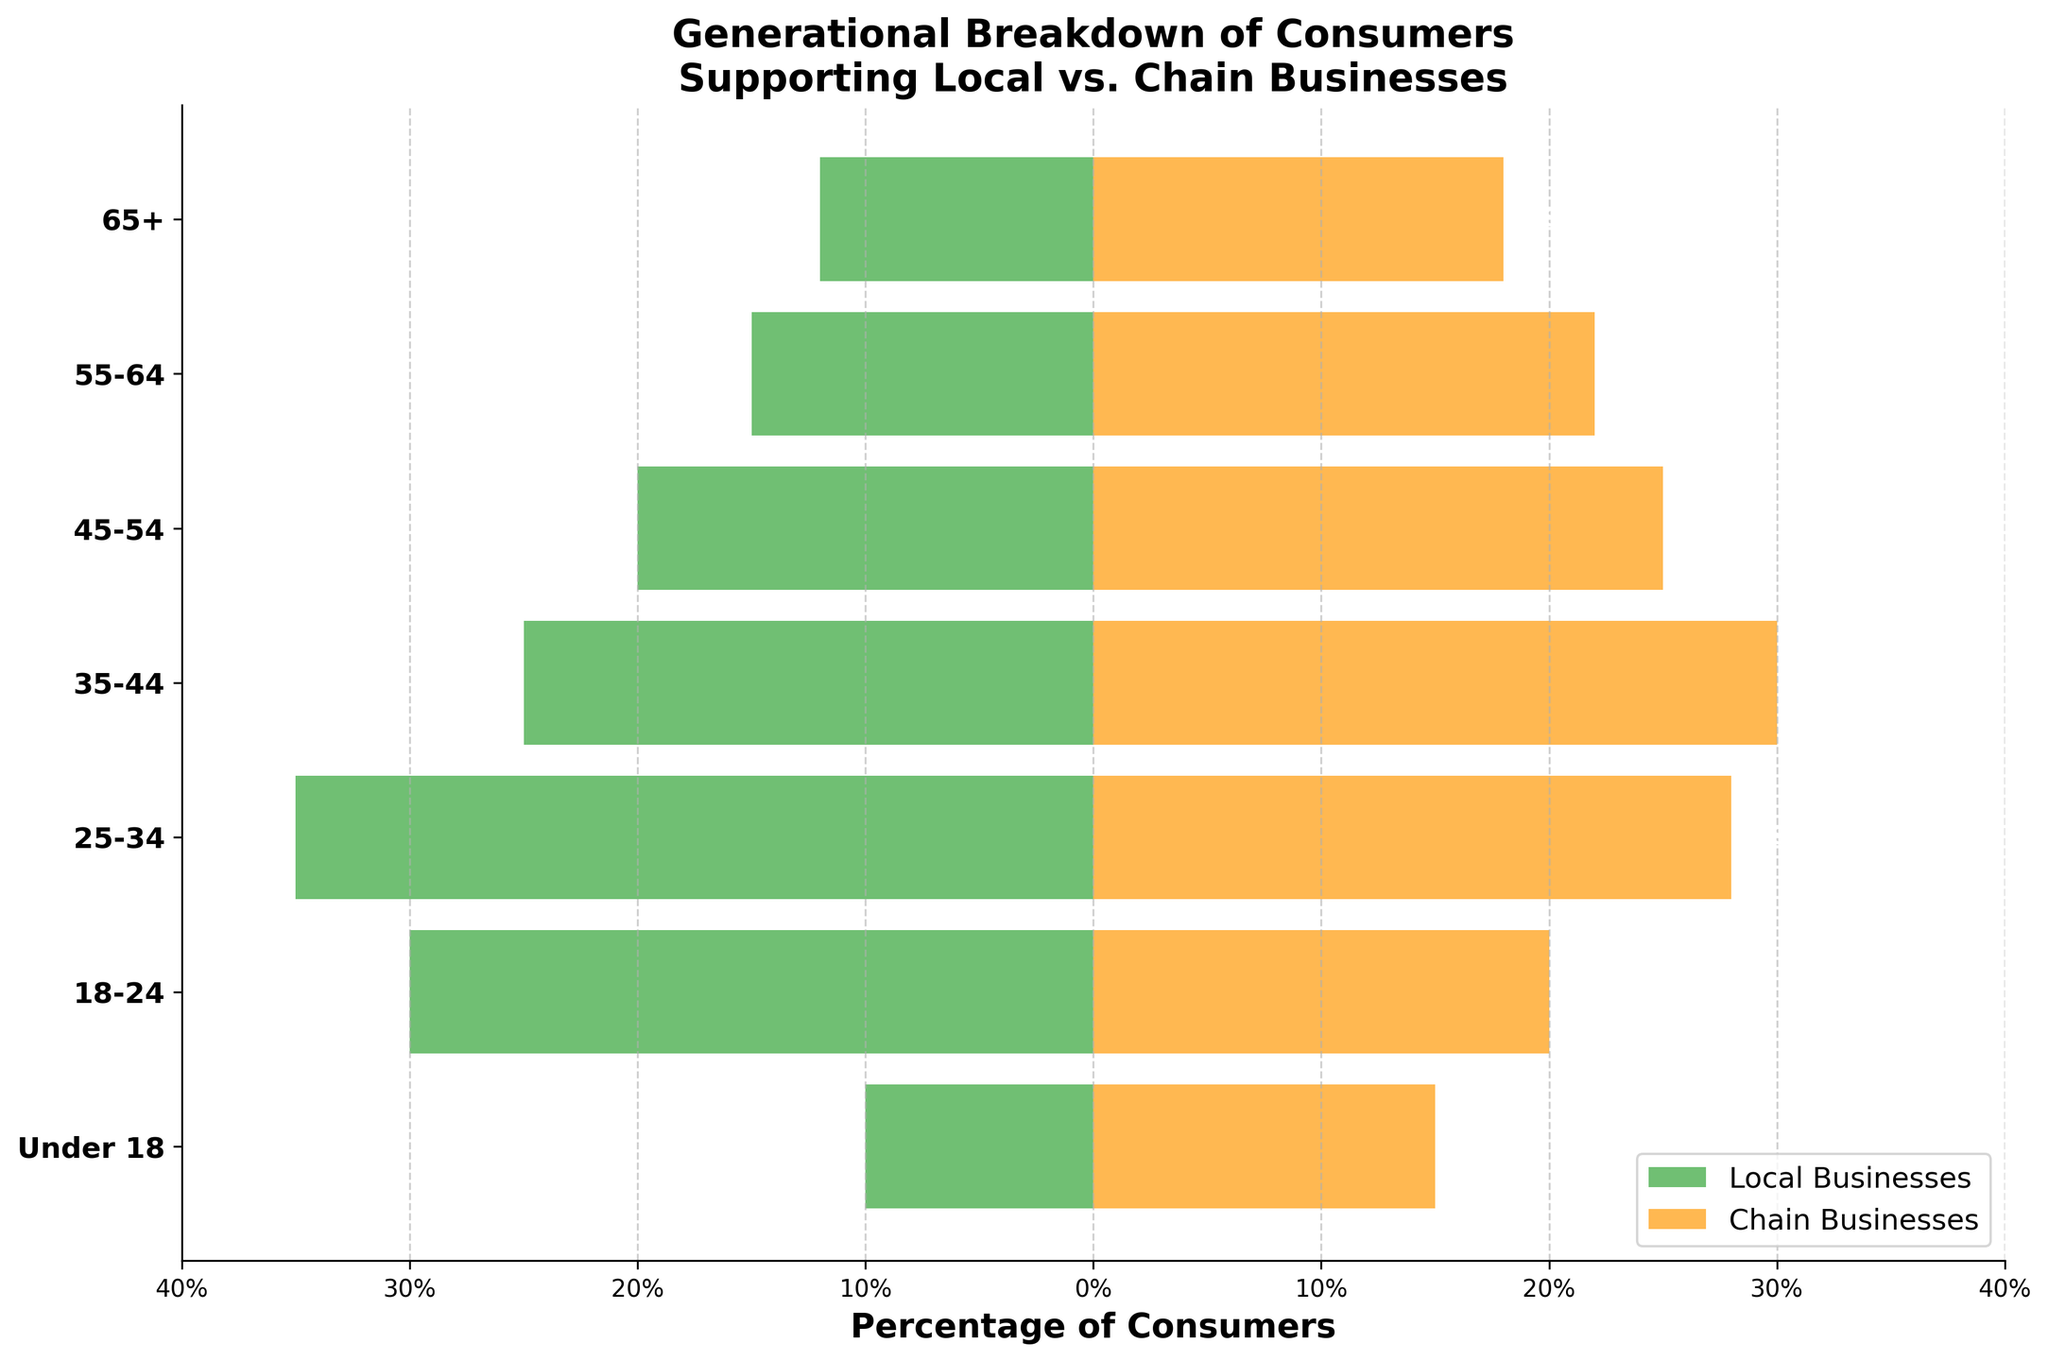What's the title of the figure? The title of a figure is typically placed at the top center of the figure to provide a brief description of what the data represents. In this case, the title can be read directly from the top part of the figure.
Answer: Generational Breakdown of Consumers Supporting Local vs. Chain Businesses What are the two categories compared in the figure? The categories compared in the figure are shown in the legend and represented by different colored bars. One category is represented by green bars and is labeled "Local Businesses," and the other is represented by orange bars and labeled "Chain Businesses."
Answer: Local Businesses and Chain Businesses Which age group shows the highest support for local businesses? By looking at the length of the green bars (Local Businesses) on the left side, the longest bar represents the age group with the highest support. The 25-34 age group has the longest green bar, indicating the highest support for local businesses.
Answer: 25-34 Which age group has a higher proportion supporting chain businesses compared to local businesses? By comparing the lengths of the orange bars (Chain Businesses) and the green bars (Local Businesses) for each age group, the 55-64 age group shows a significantly longer orange bar than its green counterpart.
Answer: 55-64 What's the difference in percentage points between those supporting local businesses and chain businesses in the 18-24 age group? From the figure, the green bar for local businesses in the 18-24 age group is at -30%, and the orange bar for chain businesses is at 20%. The difference is calculated by subtracting (-30%) from 20%, resulting in a difference of 50 percentage points.
Answer: 50 percentage points Which age group has the smallest difference between the percentages supporting local and chain businesses? This requires examining the lengths of both green and orange bars across all age groups and finding the smallest absolute difference. The 65+ age group has the smallest difference with -12% for local businesses and 18% for chain businesses, a difference of 6 percentage points.
Answer: 65+ Does the "Under 18" age group show higher support for local or chain businesses? By checking the lengths of the bars for the "Under 18" age group, it can be seen that the green bar (local businesses) at -10% is shorter than the orange bar (chain businesses) at 15%. This indicates a higher support for chain businesses.
Answer: Chain businesses How many age groups show higher support for chain businesses than local businesses? Counting the age groups where the orange bar is longer than the green bar, there are four such age groups: 65+, 55-64, 18-24, and Under 18.
Answer: 4 age groups Which age group shows the highest support for chain businesses? The longest orange bar represents the age group with the highest support for chain businesses. The 35-44 age group has the longest orange bar, indicating the highest support for chain businesses at 30%.
Answer: 35-44 